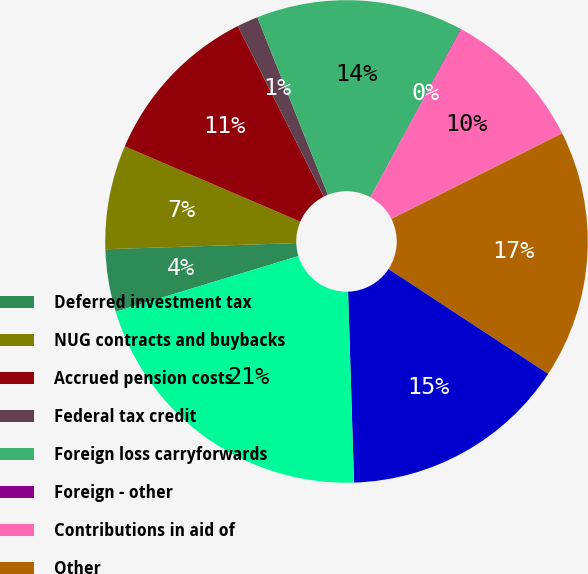Convert chart. <chart><loc_0><loc_0><loc_500><loc_500><pie_chart><fcel>Deferred investment tax<fcel>NUG contracts and buybacks<fcel>Accrued pension costs<fcel>Federal tax credit<fcel>Foreign loss carryforwards<fcel>Foreign - other<fcel>Contributions in aid of<fcel>Other<fcel>Valuation allowances<fcel>Plant - net<nl><fcel>4.19%<fcel>6.96%<fcel>11.11%<fcel>1.42%<fcel>13.87%<fcel>0.04%<fcel>9.72%<fcel>16.64%<fcel>15.26%<fcel>20.79%<nl></chart> 